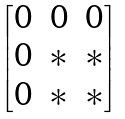<formula> <loc_0><loc_0><loc_500><loc_500>\begin{bmatrix} 0 & 0 & 0 \\ 0 & \ast & \ast \\ 0 & \ast & \ast \end{bmatrix}</formula> 